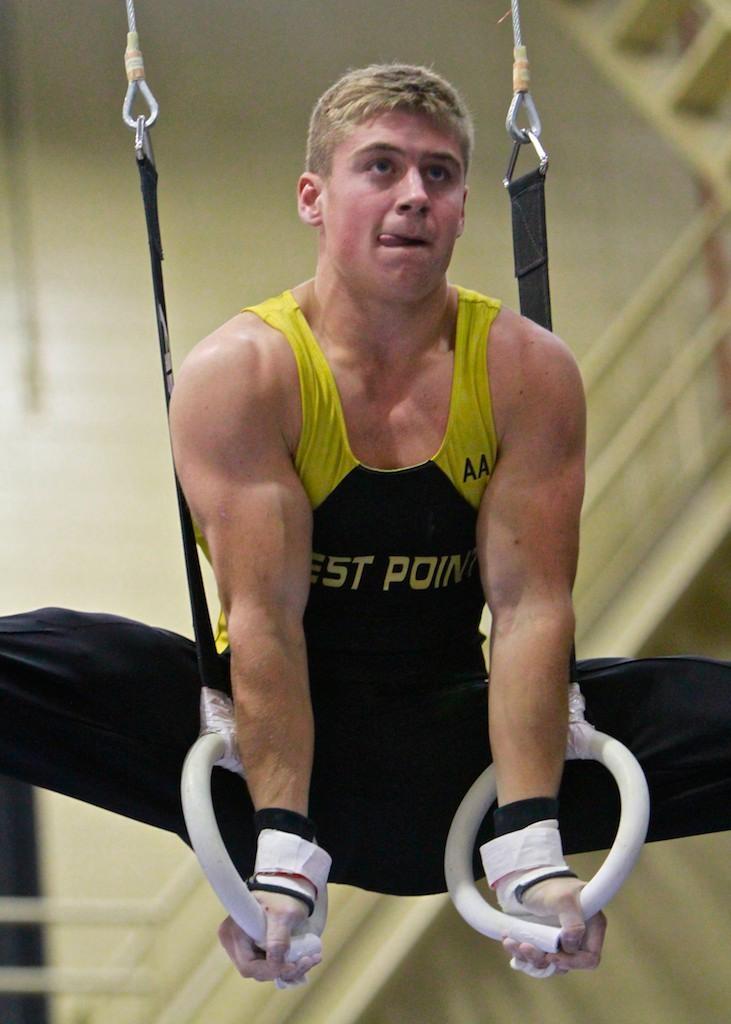Describe this image in one or two sentences. In this image, we can see a person performing an exercise with the rings and in the background, there is a wall. 